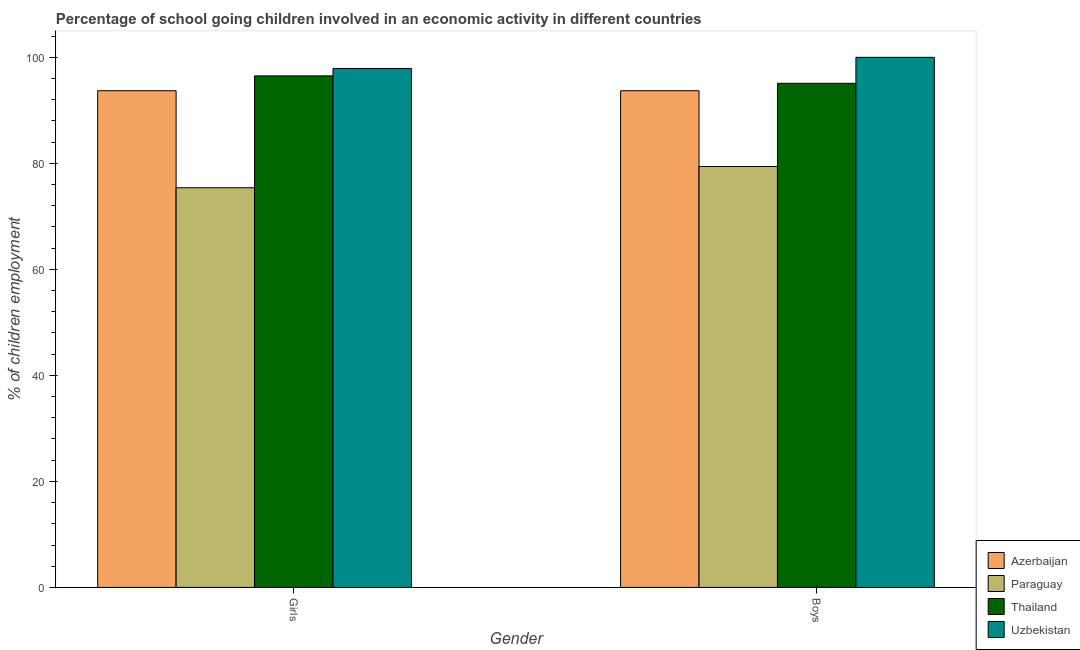How many different coloured bars are there?
Your answer should be compact. 4. How many groups of bars are there?
Give a very brief answer. 2. How many bars are there on the 2nd tick from the left?
Your answer should be very brief. 4. What is the label of the 1st group of bars from the left?
Offer a terse response. Girls. What is the percentage of school going girls in Paraguay?
Provide a short and direct response. 75.4. Across all countries, what is the minimum percentage of school going boys?
Your response must be concise. 79.4. In which country was the percentage of school going boys maximum?
Make the answer very short. Uzbekistan. In which country was the percentage of school going girls minimum?
Provide a short and direct response. Paraguay. What is the total percentage of school going girls in the graph?
Your answer should be very brief. 363.5. What is the difference between the percentage of school going boys in Paraguay and that in Thailand?
Offer a very short reply. -15.7. What is the difference between the percentage of school going boys in Azerbaijan and the percentage of school going girls in Uzbekistan?
Keep it short and to the point. -4.2. What is the average percentage of school going girls per country?
Offer a very short reply. 90.88. What is the difference between the percentage of school going girls and percentage of school going boys in Azerbaijan?
Provide a short and direct response. 0. What is the ratio of the percentage of school going boys in Thailand to that in Paraguay?
Make the answer very short. 1.2. Is the percentage of school going girls in Azerbaijan less than that in Paraguay?
Your answer should be very brief. No. What does the 3rd bar from the left in Boys represents?
Give a very brief answer. Thailand. What does the 1st bar from the right in Girls represents?
Your answer should be compact. Uzbekistan. Are all the bars in the graph horizontal?
Ensure brevity in your answer.  No. How many countries are there in the graph?
Offer a very short reply. 4. What is the difference between two consecutive major ticks on the Y-axis?
Provide a succinct answer. 20. Are the values on the major ticks of Y-axis written in scientific E-notation?
Provide a short and direct response. No. Does the graph contain any zero values?
Ensure brevity in your answer.  No. How many legend labels are there?
Make the answer very short. 4. What is the title of the graph?
Ensure brevity in your answer.  Percentage of school going children involved in an economic activity in different countries. Does "Paraguay" appear as one of the legend labels in the graph?
Your response must be concise. Yes. What is the label or title of the X-axis?
Your answer should be very brief. Gender. What is the label or title of the Y-axis?
Your answer should be very brief. % of children employment. What is the % of children employment in Azerbaijan in Girls?
Offer a terse response. 93.7. What is the % of children employment of Paraguay in Girls?
Your response must be concise. 75.4. What is the % of children employment of Thailand in Girls?
Provide a short and direct response. 96.5. What is the % of children employment of Uzbekistan in Girls?
Your answer should be compact. 97.9. What is the % of children employment in Azerbaijan in Boys?
Your answer should be very brief. 93.7. What is the % of children employment in Paraguay in Boys?
Offer a very short reply. 79.4. What is the % of children employment of Thailand in Boys?
Your answer should be very brief. 95.1. What is the % of children employment of Uzbekistan in Boys?
Provide a succinct answer. 100. Across all Gender, what is the maximum % of children employment of Azerbaijan?
Offer a terse response. 93.7. Across all Gender, what is the maximum % of children employment of Paraguay?
Your response must be concise. 79.4. Across all Gender, what is the maximum % of children employment of Thailand?
Your response must be concise. 96.5. Across all Gender, what is the maximum % of children employment of Uzbekistan?
Your answer should be very brief. 100. Across all Gender, what is the minimum % of children employment of Azerbaijan?
Your answer should be compact. 93.7. Across all Gender, what is the minimum % of children employment of Paraguay?
Your answer should be very brief. 75.4. Across all Gender, what is the minimum % of children employment of Thailand?
Give a very brief answer. 95.1. Across all Gender, what is the minimum % of children employment of Uzbekistan?
Your answer should be compact. 97.9. What is the total % of children employment of Azerbaijan in the graph?
Provide a short and direct response. 187.4. What is the total % of children employment of Paraguay in the graph?
Your answer should be very brief. 154.8. What is the total % of children employment in Thailand in the graph?
Your response must be concise. 191.6. What is the total % of children employment of Uzbekistan in the graph?
Make the answer very short. 197.9. What is the difference between the % of children employment in Azerbaijan in Girls and that in Boys?
Ensure brevity in your answer.  0. What is the difference between the % of children employment in Uzbekistan in Girls and that in Boys?
Give a very brief answer. -2.1. What is the difference between the % of children employment in Azerbaijan in Girls and the % of children employment in Paraguay in Boys?
Make the answer very short. 14.3. What is the difference between the % of children employment of Azerbaijan in Girls and the % of children employment of Thailand in Boys?
Ensure brevity in your answer.  -1.4. What is the difference between the % of children employment in Azerbaijan in Girls and the % of children employment in Uzbekistan in Boys?
Ensure brevity in your answer.  -6.3. What is the difference between the % of children employment of Paraguay in Girls and the % of children employment of Thailand in Boys?
Offer a terse response. -19.7. What is the difference between the % of children employment in Paraguay in Girls and the % of children employment in Uzbekistan in Boys?
Offer a very short reply. -24.6. What is the average % of children employment in Azerbaijan per Gender?
Make the answer very short. 93.7. What is the average % of children employment of Paraguay per Gender?
Give a very brief answer. 77.4. What is the average % of children employment in Thailand per Gender?
Keep it short and to the point. 95.8. What is the average % of children employment in Uzbekistan per Gender?
Your response must be concise. 98.95. What is the difference between the % of children employment in Azerbaijan and % of children employment in Paraguay in Girls?
Your response must be concise. 18.3. What is the difference between the % of children employment in Azerbaijan and % of children employment in Uzbekistan in Girls?
Ensure brevity in your answer.  -4.2. What is the difference between the % of children employment of Paraguay and % of children employment of Thailand in Girls?
Your answer should be compact. -21.1. What is the difference between the % of children employment of Paraguay and % of children employment of Uzbekistan in Girls?
Your answer should be very brief. -22.5. What is the difference between the % of children employment of Azerbaijan and % of children employment of Paraguay in Boys?
Your answer should be very brief. 14.3. What is the difference between the % of children employment in Azerbaijan and % of children employment in Uzbekistan in Boys?
Provide a short and direct response. -6.3. What is the difference between the % of children employment in Paraguay and % of children employment in Thailand in Boys?
Ensure brevity in your answer.  -15.7. What is the difference between the % of children employment of Paraguay and % of children employment of Uzbekistan in Boys?
Provide a succinct answer. -20.6. What is the difference between the % of children employment of Thailand and % of children employment of Uzbekistan in Boys?
Your answer should be very brief. -4.9. What is the ratio of the % of children employment in Paraguay in Girls to that in Boys?
Keep it short and to the point. 0.95. What is the ratio of the % of children employment in Thailand in Girls to that in Boys?
Give a very brief answer. 1.01. What is the ratio of the % of children employment in Uzbekistan in Girls to that in Boys?
Your response must be concise. 0.98. What is the difference between the highest and the second highest % of children employment in Azerbaijan?
Keep it short and to the point. 0. What is the difference between the highest and the lowest % of children employment in Azerbaijan?
Provide a short and direct response. 0. What is the difference between the highest and the lowest % of children employment of Paraguay?
Provide a short and direct response. 4. What is the difference between the highest and the lowest % of children employment in Thailand?
Make the answer very short. 1.4. What is the difference between the highest and the lowest % of children employment in Uzbekistan?
Offer a very short reply. 2.1. 